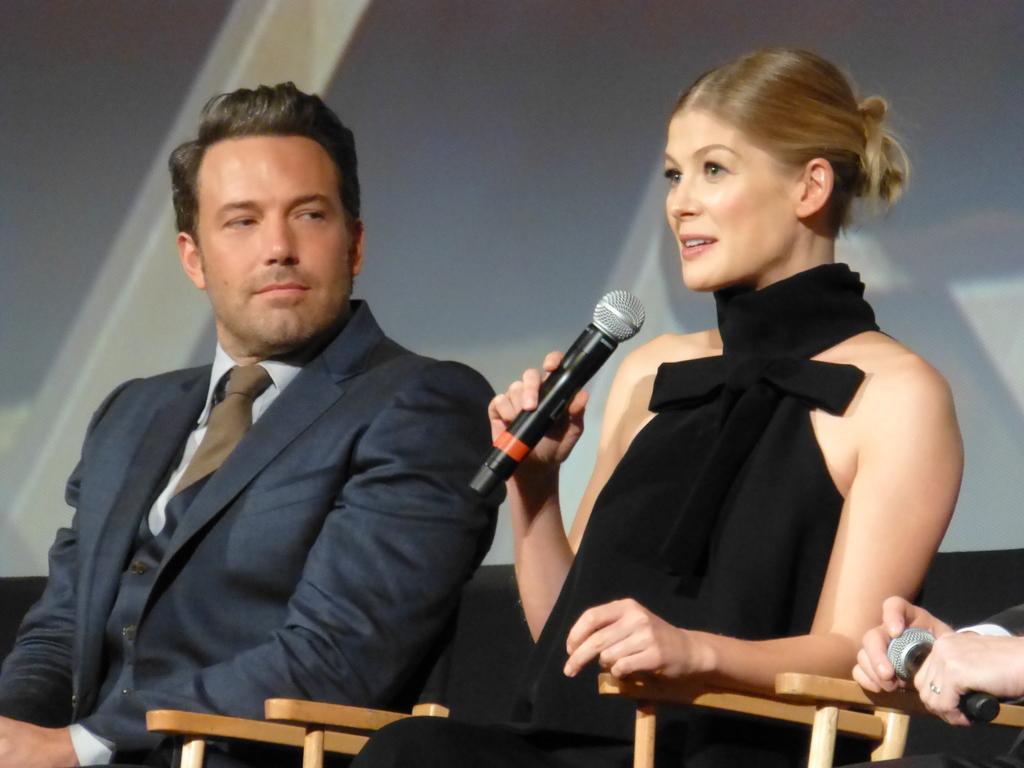Describe this image in one or two sentences. In this image we can see a group of people sitting on chairs. One woman is holding a microphone in her hands. On the right side of the image we can see the hands of a person holding microphone. In the background, we can see a screen. 